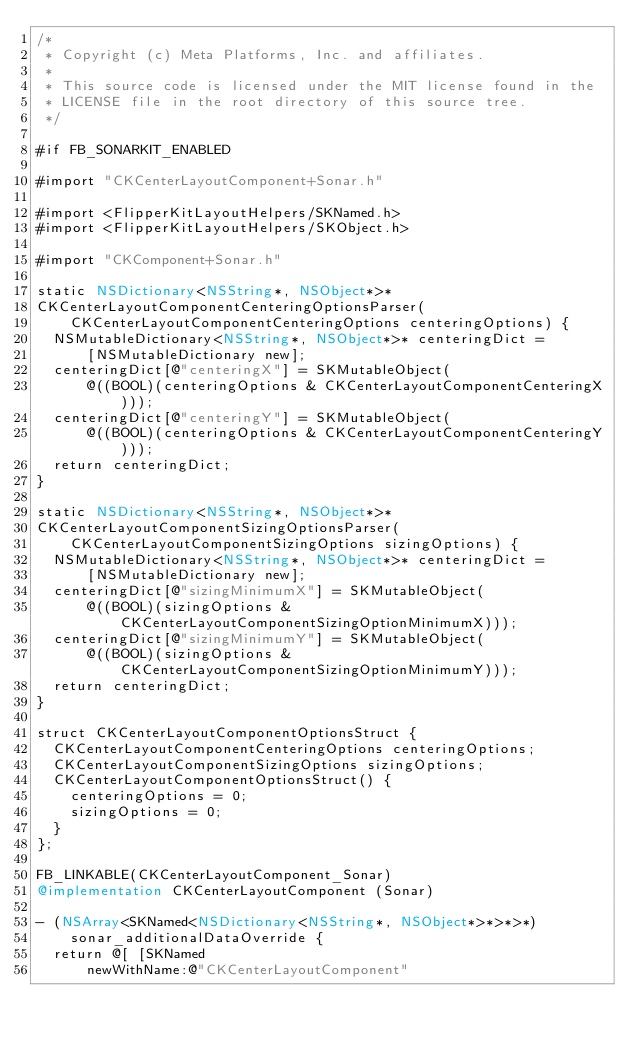<code> <loc_0><loc_0><loc_500><loc_500><_ObjectiveC_>/*
 * Copyright (c) Meta Platforms, Inc. and affiliates.
 *
 * This source code is licensed under the MIT license found in the
 * LICENSE file in the root directory of this source tree.
 */

#if FB_SONARKIT_ENABLED

#import "CKCenterLayoutComponent+Sonar.h"

#import <FlipperKitLayoutHelpers/SKNamed.h>
#import <FlipperKitLayoutHelpers/SKObject.h>

#import "CKComponent+Sonar.h"

static NSDictionary<NSString*, NSObject*>*
CKCenterLayoutComponentCenteringOptionsParser(
    CKCenterLayoutComponentCenteringOptions centeringOptions) {
  NSMutableDictionary<NSString*, NSObject*>* centeringDict =
      [NSMutableDictionary new];
  centeringDict[@"centeringX"] = SKMutableObject(
      @((BOOL)(centeringOptions & CKCenterLayoutComponentCenteringX)));
  centeringDict[@"centeringY"] = SKMutableObject(
      @((BOOL)(centeringOptions & CKCenterLayoutComponentCenteringY)));
  return centeringDict;
}

static NSDictionary<NSString*, NSObject*>*
CKCenterLayoutComponentSizingOptionsParser(
    CKCenterLayoutComponentSizingOptions sizingOptions) {
  NSMutableDictionary<NSString*, NSObject*>* centeringDict =
      [NSMutableDictionary new];
  centeringDict[@"sizingMinimumX"] = SKMutableObject(
      @((BOOL)(sizingOptions & CKCenterLayoutComponentSizingOptionMinimumX)));
  centeringDict[@"sizingMinimumY"] = SKMutableObject(
      @((BOOL)(sizingOptions & CKCenterLayoutComponentSizingOptionMinimumY)));
  return centeringDict;
}

struct CKCenterLayoutComponentOptionsStruct {
  CKCenterLayoutComponentCenteringOptions centeringOptions;
  CKCenterLayoutComponentSizingOptions sizingOptions;
  CKCenterLayoutComponentOptionsStruct() {
    centeringOptions = 0;
    sizingOptions = 0;
  }
};

FB_LINKABLE(CKCenterLayoutComponent_Sonar)
@implementation CKCenterLayoutComponent (Sonar)

- (NSArray<SKNamed<NSDictionary<NSString*, NSObject*>*>*>*)
    sonar_additionalDataOverride {
  return @[ [SKNamed
      newWithName:@"CKCenterLayoutComponent"</code> 